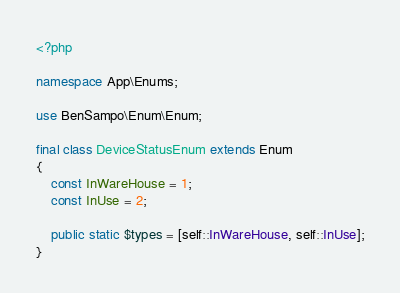Convert code to text. <code><loc_0><loc_0><loc_500><loc_500><_PHP_><?php

namespace App\Enums;

use BenSampo\Enum\Enum;

final class DeviceStatusEnum extends Enum
{
	const InWareHouse = 1;
	const InUse = 2;

	public static $types = [self::InWareHouse, self::InUse];
}
</code> 